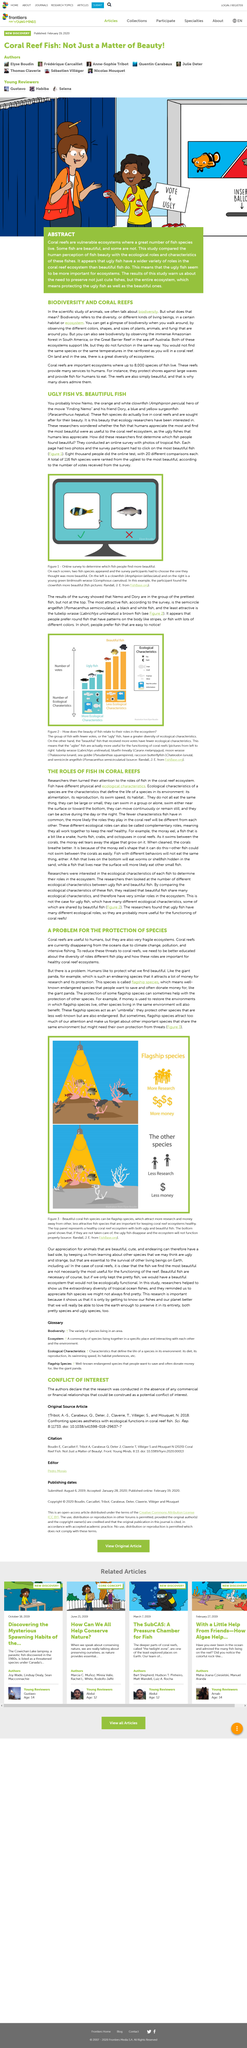Identify some key points in this picture. Coral reefs are extremely useful to humans in a variety of ways. The fish that are categorized as ugly have fewer ecological characteristics than those that are not considered ugly. The semicircle angelfish is a day or night fish. According to the survey, the semicircle angelfish was the most attractive fish. Climate change is a significant reason why coral reefs are disappearing from the oceans. 